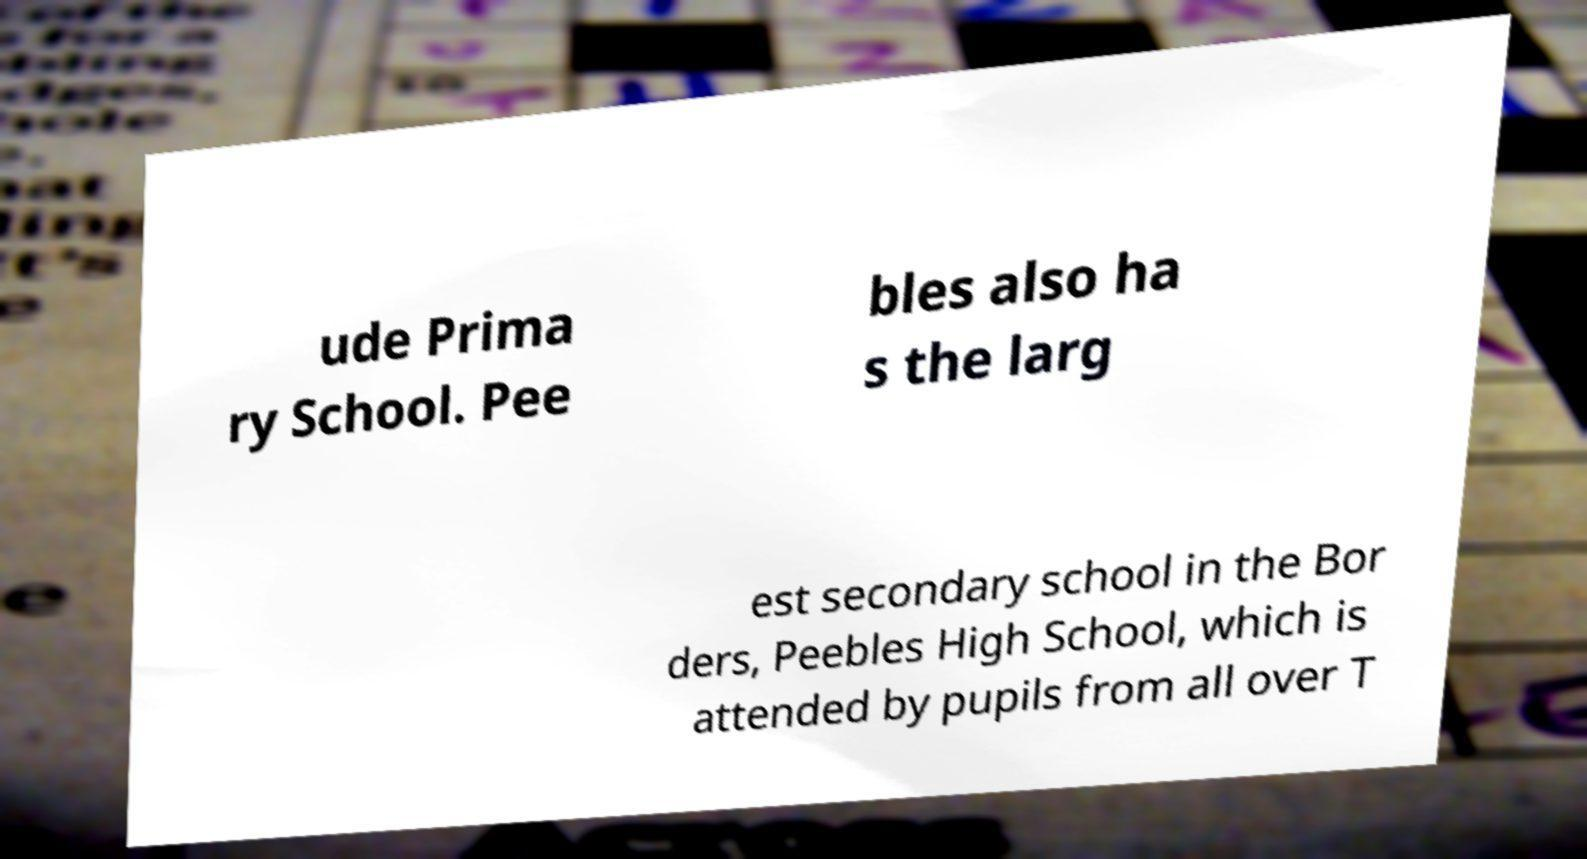Please read and relay the text visible in this image. What does it say? ude Prima ry School. Pee bles also ha s the larg est secondary school in the Bor ders, Peebles High School, which is attended by pupils from all over T 